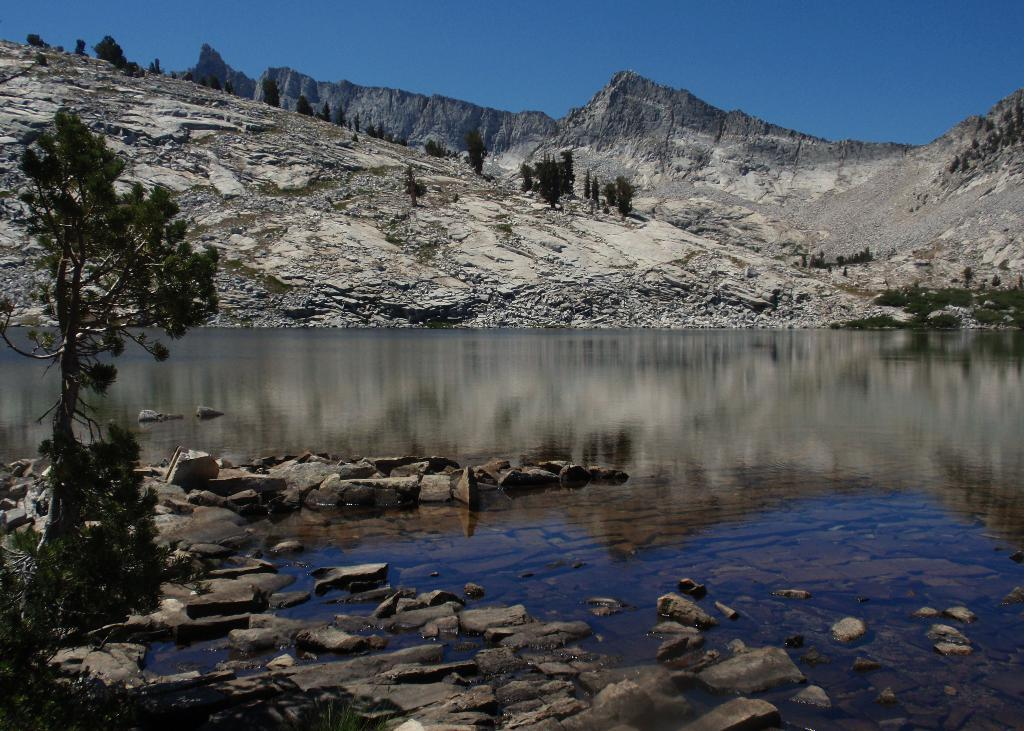What natural element is visible in the image? The sky is visible in the image. What type of landform can be seen in the image? There are hills in the image. What type of vegetation is present in the image? Trees are present in the image. What type of geological feature is visible in the image? Stones are visible in the image. What body of water is present in the image? There is water in the image. What is the name of the wilderness area depicted in the image? There is no specific wilderness area mentioned or depicted in the image, so it is not possible to provide a name. 